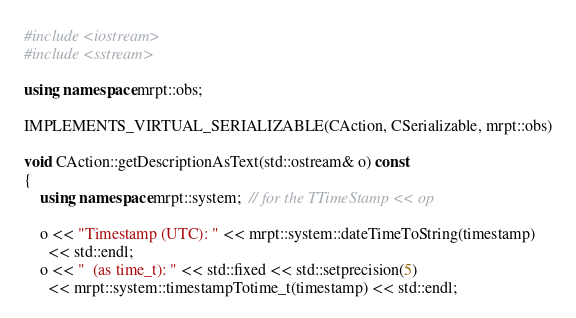<code> <loc_0><loc_0><loc_500><loc_500><_C++_>#include <iostream>
#include <sstream>

using namespace mrpt::obs;

IMPLEMENTS_VIRTUAL_SERIALIZABLE(CAction, CSerializable, mrpt::obs)

void CAction::getDescriptionAsText(std::ostream& o) const
{
	using namespace mrpt::system;  // for the TTimeStamp << op

	o << "Timestamp (UTC): " << mrpt::system::dateTimeToString(timestamp)
	  << std::endl;
	o << "  (as time_t): " << std::fixed << std::setprecision(5)
	  << mrpt::system::timestampTotime_t(timestamp) << std::endl;</code> 